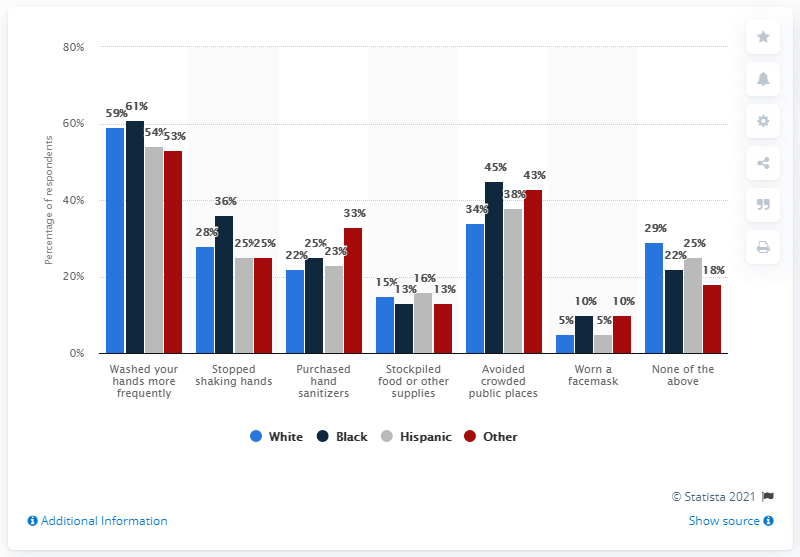Indicate a few pertinent items in this graphic. The light blue color indicates that the item is white. As of March 11, 2020, 36% of individuals have stopped shaking hands due to the COVID-19 pandemic. 